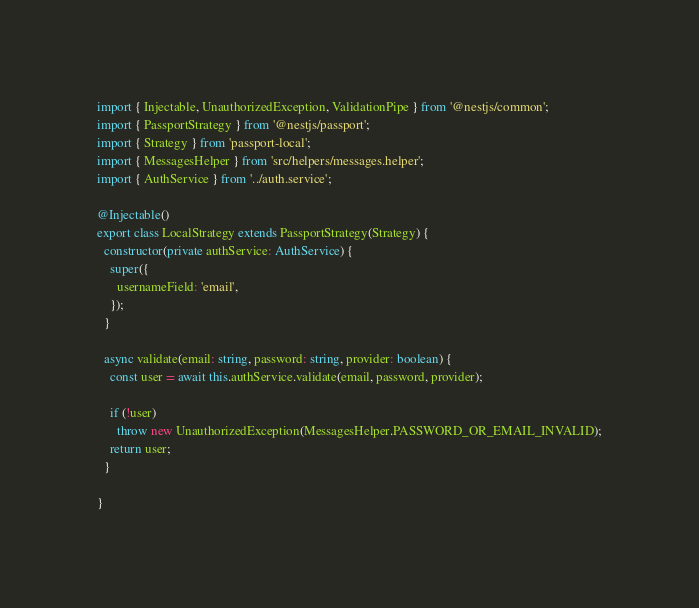<code> <loc_0><loc_0><loc_500><loc_500><_TypeScript_>import { Injectable, UnauthorizedException, ValidationPipe } from '@nestjs/common';
import { PassportStrategy } from '@nestjs/passport';
import { Strategy } from 'passport-local';
import { MessagesHelper } from 'src/helpers/messages.helper';
import { AuthService } from '../auth.service';

@Injectable()
export class LocalStrategy extends PassportStrategy(Strategy) {
  constructor(private authService: AuthService) {
    super({
      usernameField: 'email',
    });
  }

  async validate(email: string, password: string, provider: boolean) {
    const user = await this.authService.validate(email, password, provider);

    if (!user)
      throw new UnauthorizedException(MessagesHelper.PASSWORD_OR_EMAIL_INVALID);
    return user;
  }

}
</code> 